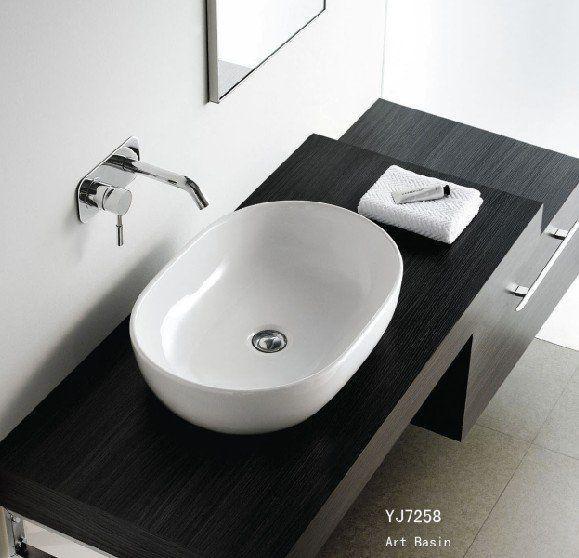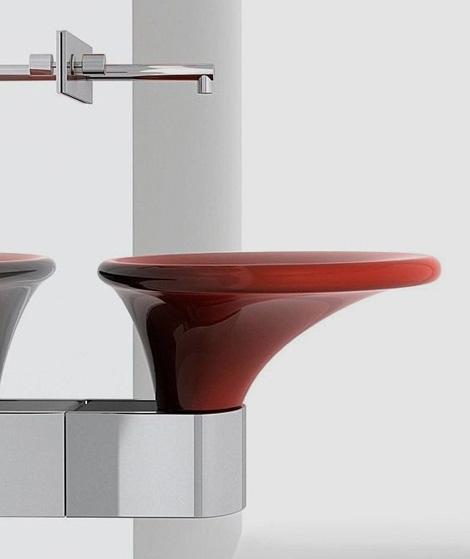The first image is the image on the left, the second image is the image on the right. Examine the images to the left and right. Is the description "One sink has a gooseneck faucet with a turned-down curved spout." accurate? Answer yes or no. No. 